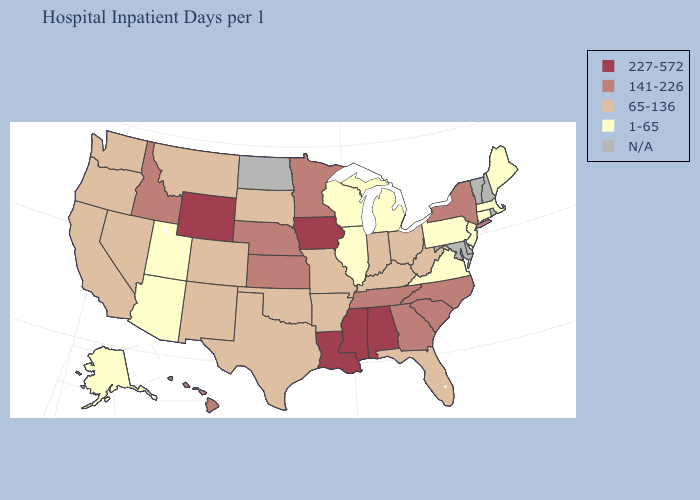Does Pennsylvania have the lowest value in the USA?
Be succinct. Yes. Name the states that have a value in the range 65-136?
Answer briefly. Arkansas, California, Colorado, Florida, Indiana, Kentucky, Missouri, Montana, Nevada, New Mexico, Ohio, Oklahoma, Oregon, South Dakota, Texas, Washington, West Virginia. Does Iowa have the highest value in the USA?
Keep it brief. Yes. What is the value of New Hampshire?
Quick response, please. N/A. Does Kentucky have the lowest value in the USA?
Give a very brief answer. No. Which states hav the highest value in the MidWest?
Give a very brief answer. Iowa. What is the value of Nevada?
Short answer required. 65-136. Among the states that border Kentucky , does Ohio have the lowest value?
Keep it brief. No. What is the value of Oregon?
Write a very short answer. 65-136. What is the value of Indiana?
Quick response, please. 65-136. What is the highest value in states that border Maryland?
Be succinct. 65-136. Which states have the lowest value in the USA?
Write a very short answer. Alaska, Arizona, Connecticut, Illinois, Maine, Massachusetts, Michigan, New Jersey, Pennsylvania, Utah, Virginia, Wisconsin. Among the states that border New Jersey , which have the lowest value?
Give a very brief answer. Pennsylvania. 